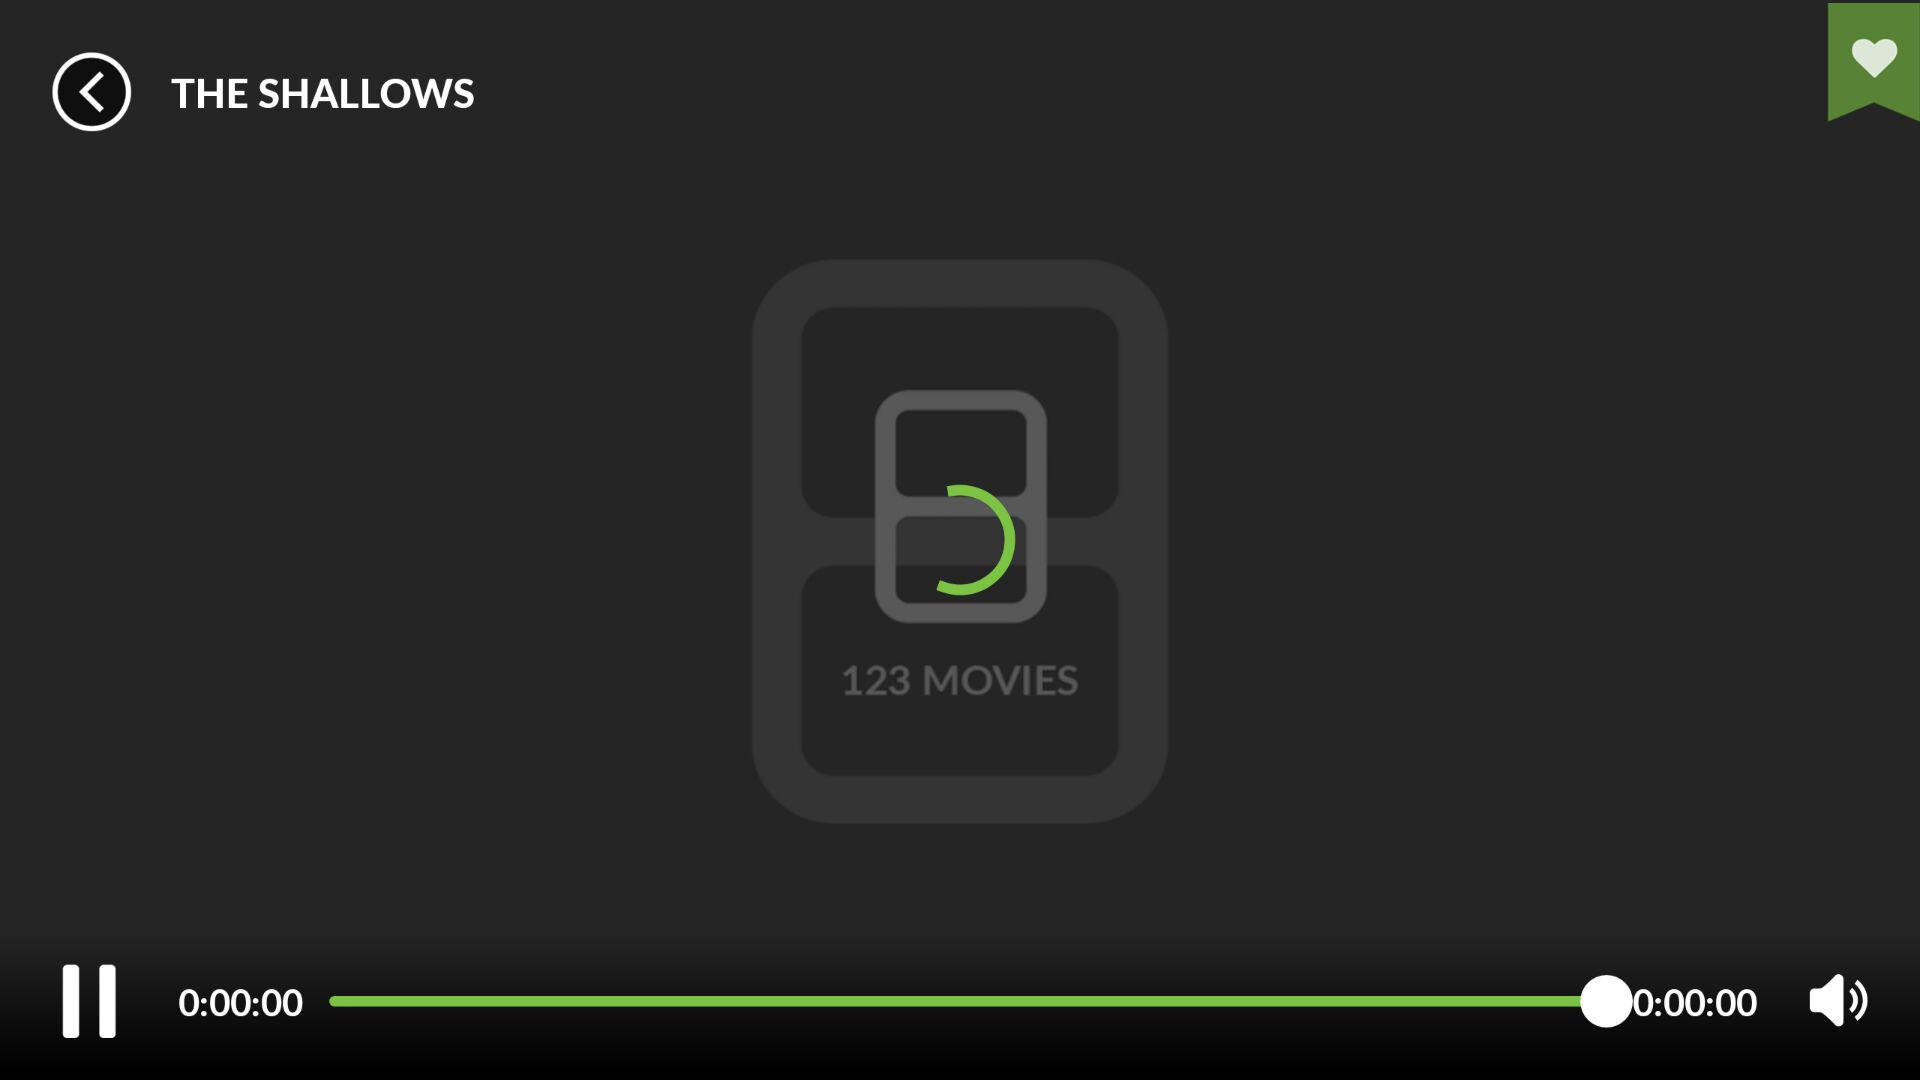What is the number of movies? The number of movies is 123. 